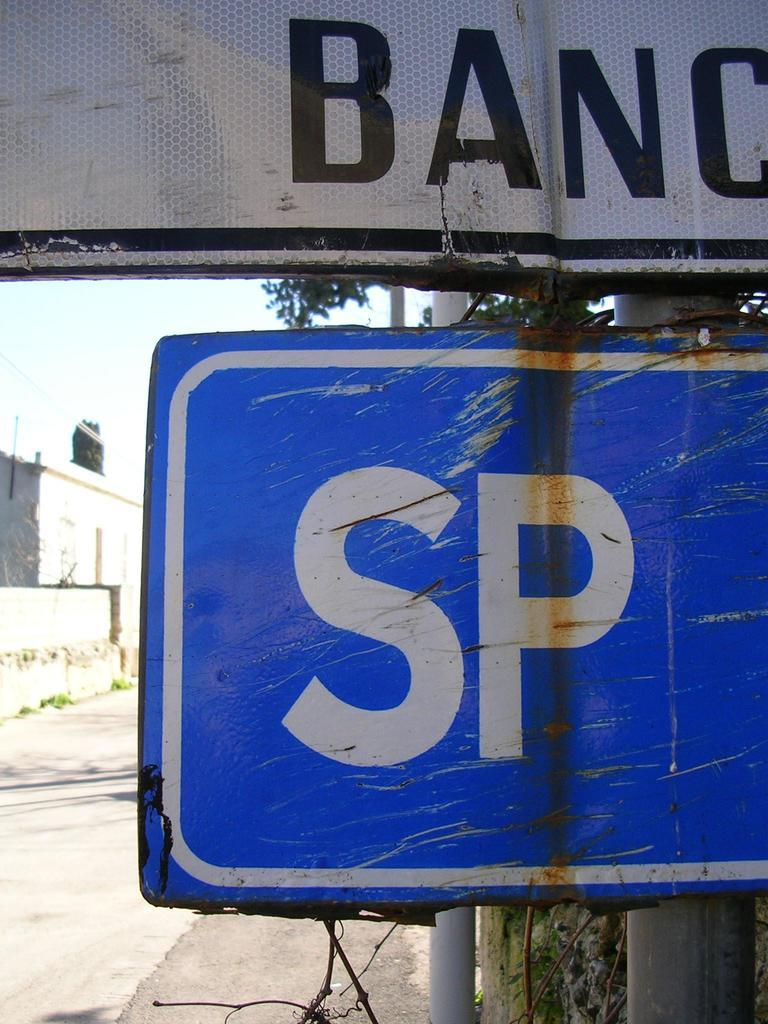<image>
Write a terse but informative summary of the picture. Blue sign that says SP under a white sign. 